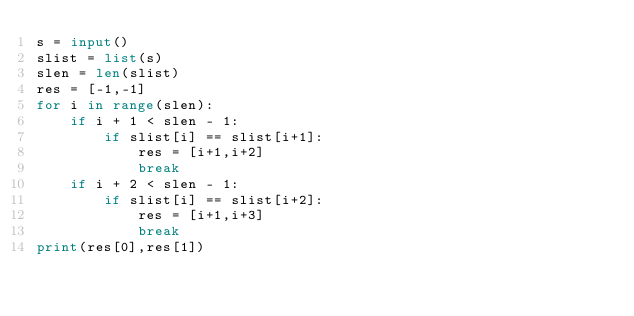Convert code to text. <code><loc_0><loc_0><loc_500><loc_500><_Python_>s = input()
slist = list(s)
slen = len(slist)
res = [-1,-1]
for i in range(slen):
    if i + 1 < slen - 1:
        if slist[i] == slist[i+1]:
            res = [i+1,i+2]
            break
    if i + 2 < slen - 1:
        if slist[i] == slist[i+2]:
            res = [i+1,i+3]
            break
print(res[0],res[1])
</code> 